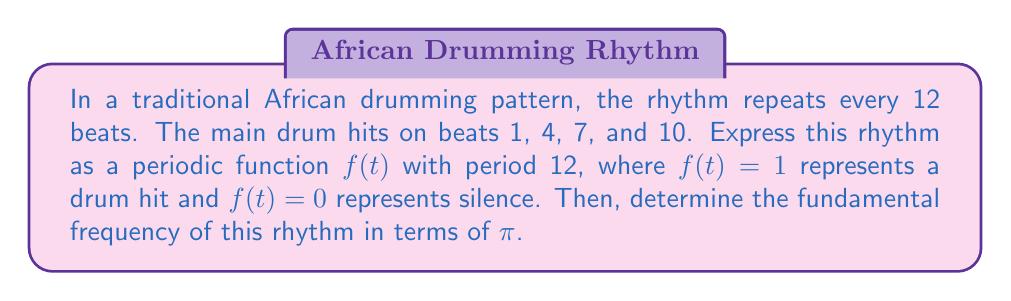Provide a solution to this math problem. Let's approach this step-by-step:

1) First, we need to create a periodic function that represents the drum pattern. We can use a sum of delta functions for this:

   $$f(t) = \sum_{n=-\infty}^{\infty} [\delta(t-12n) + \delta(t-12n-3) + \delta(t-12n-6) + \delta(t-12n-9)]$$

   This function has a value of 1 at beats 1, 4, 7, and 10 (and their periodic repetitions), and 0 elsewhere.

2) The period of this function is 12 beats. In the context of periodic functions, we typically express the period in terms of $2\pi$. So, we can say:

   $$12 \text{ beats} = 2\pi \text{ radians}$$

3) To find the fundamental frequency, we need to determine how many cycles occur in $2\pi$ radians. Let's call our fundamental frequency $\omega_0$:

   $$\omega_0 \cdot 12 \text{ beats} = 2\pi \text{ radians}$$

4) Solving for $\omega_0$:

   $$\omega_0 = \frac{2\pi}{12} = \frac{\pi}{6} \text{ radians/beat}$$

This means the rhythm completes one full cycle every $\frac{\pi}{6}$ radians.
Answer: $\frac{\pi}{6}$ radians/beat 